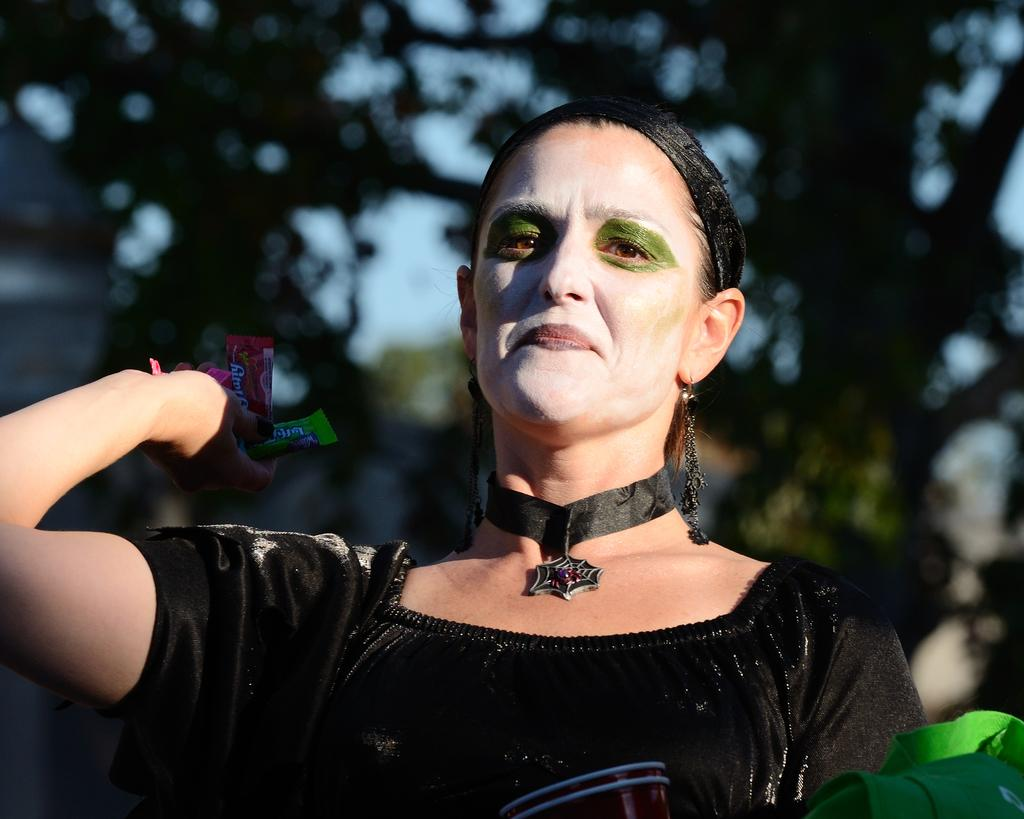Who is present in the image? There is a woman in the image. What is the woman doing in the image? The woman is standing in the image. What is the woman holding in the image? The woman is holding objects in the image. What can be seen in the background of the image? There are trees and the sky visible in the background of the image. What type of poison can be seen in the woman's hand in the image? There is no poison present in the image; the woman is holding objects, but there is no indication of what those objects are. 